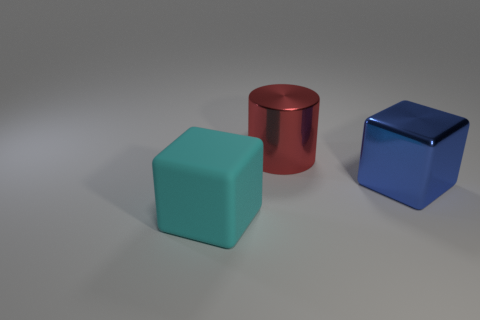Subtract all cylinders. How many objects are left? 2 Add 2 big matte blocks. How many objects exist? 5 Subtract all cylinders. Subtract all big cyan rubber blocks. How many objects are left? 1 Add 3 blue metal blocks. How many blue metal blocks are left? 4 Add 1 big gray metallic cylinders. How many big gray metallic cylinders exist? 1 Subtract 0 cyan cylinders. How many objects are left? 3 